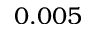Convert formula to latex. <formula><loc_0><loc_0><loc_500><loc_500>0 . 0 0 5</formula> 